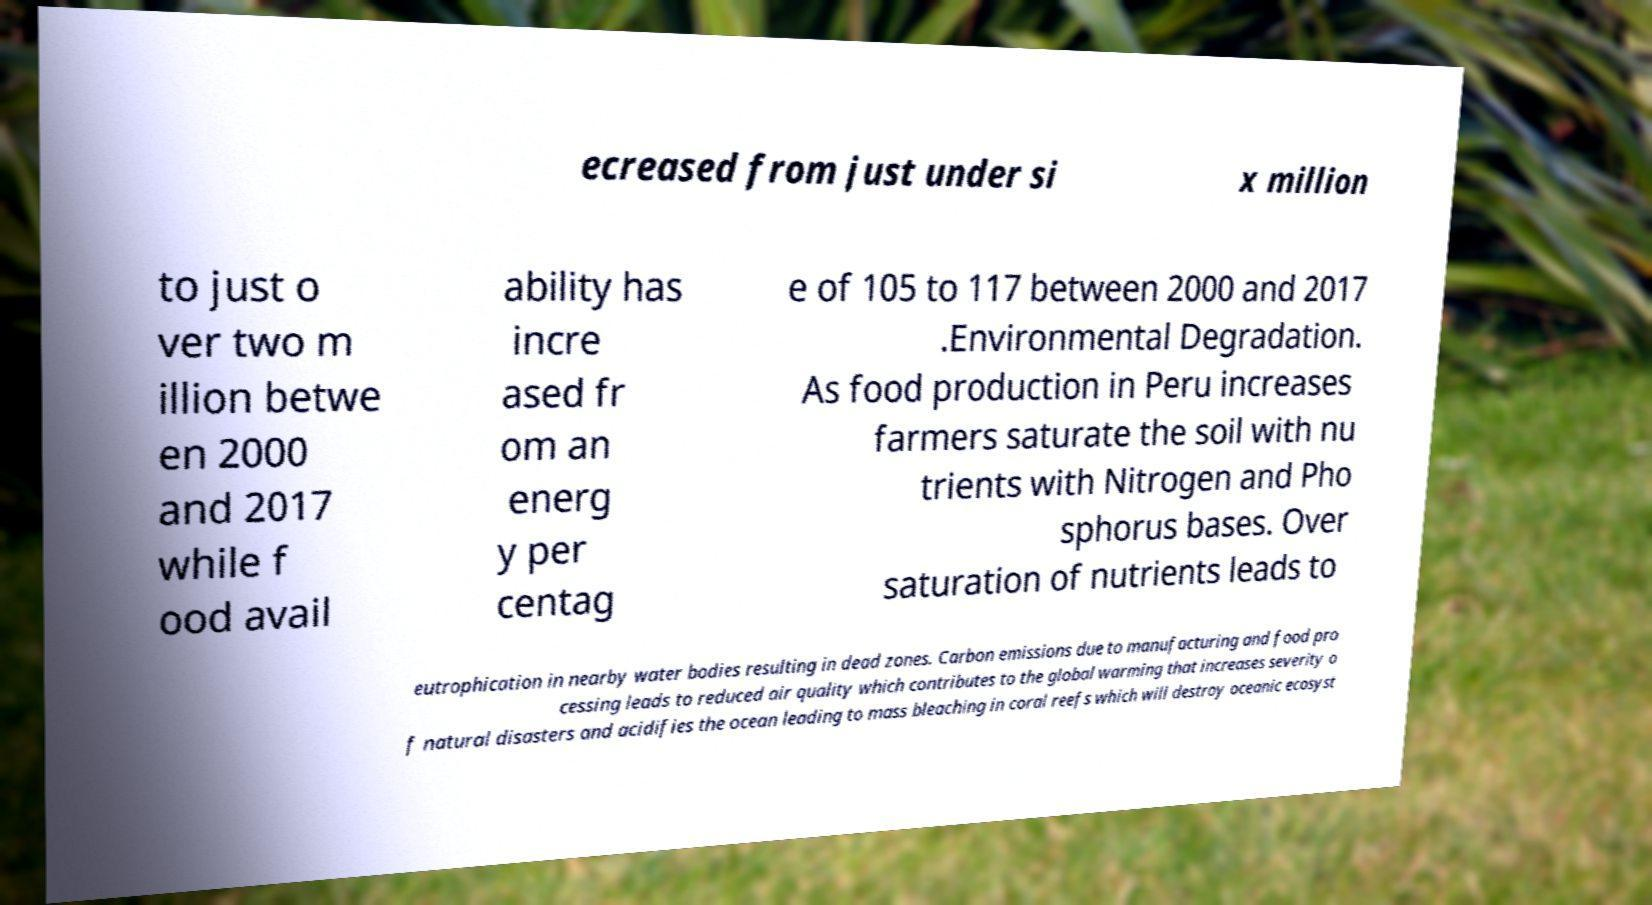Please read and relay the text visible in this image. What does it say? ecreased from just under si x million to just o ver two m illion betwe en 2000 and 2017 while f ood avail ability has incre ased fr om an energ y per centag e of 105 to 117 between 2000 and 2017 .Environmental Degradation. As food production in Peru increases farmers saturate the soil with nu trients with Nitrogen and Pho sphorus bases. Over saturation of nutrients leads to eutrophication in nearby water bodies resulting in dead zones. Carbon emissions due to manufacturing and food pro cessing leads to reduced air quality which contributes to the global warming that increases severity o f natural disasters and acidifies the ocean leading to mass bleaching in coral reefs which will destroy oceanic ecosyst 